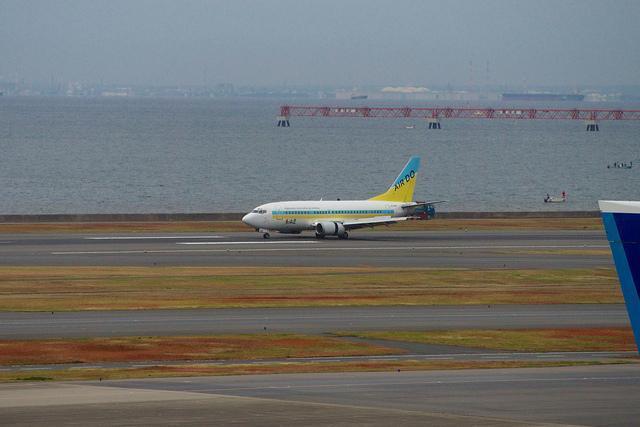How many planes are there?
Give a very brief answer. 1. How many engines are visible?
Give a very brief answer. 1. How many rolls of toilet paper are sitting on the toilet tank?
Give a very brief answer. 0. 